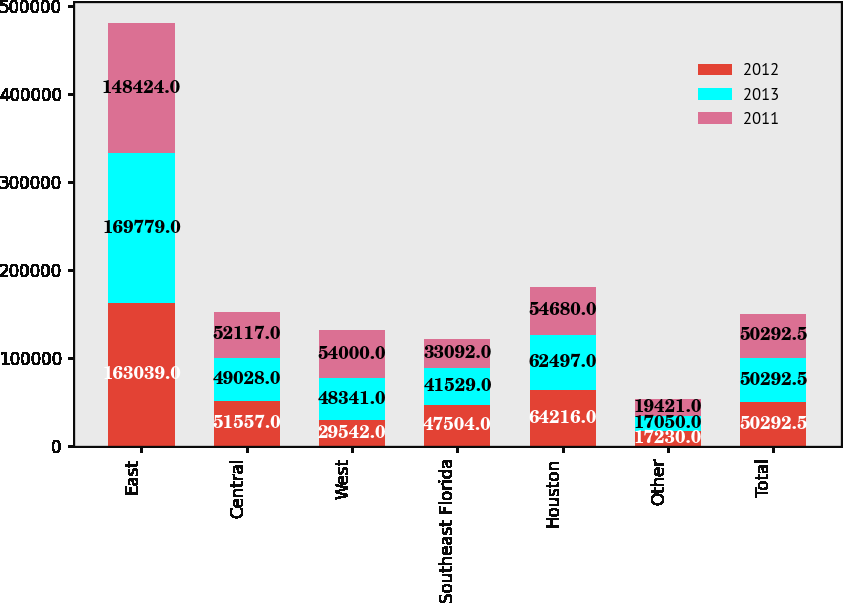<chart> <loc_0><loc_0><loc_500><loc_500><stacked_bar_chart><ecel><fcel>East<fcel>Central<fcel>West<fcel>Southeast Florida<fcel>Houston<fcel>Other<fcel>Total<nl><fcel>2012<fcel>163039<fcel>51557<fcel>29542<fcel>47504<fcel>64216<fcel>17230<fcel>50292.5<nl><fcel>2013<fcel>169779<fcel>49028<fcel>48341<fcel>41529<fcel>62497<fcel>17050<fcel>50292.5<nl><fcel>2011<fcel>148424<fcel>52117<fcel>54000<fcel>33092<fcel>54680<fcel>19421<fcel>50292.5<nl></chart> 